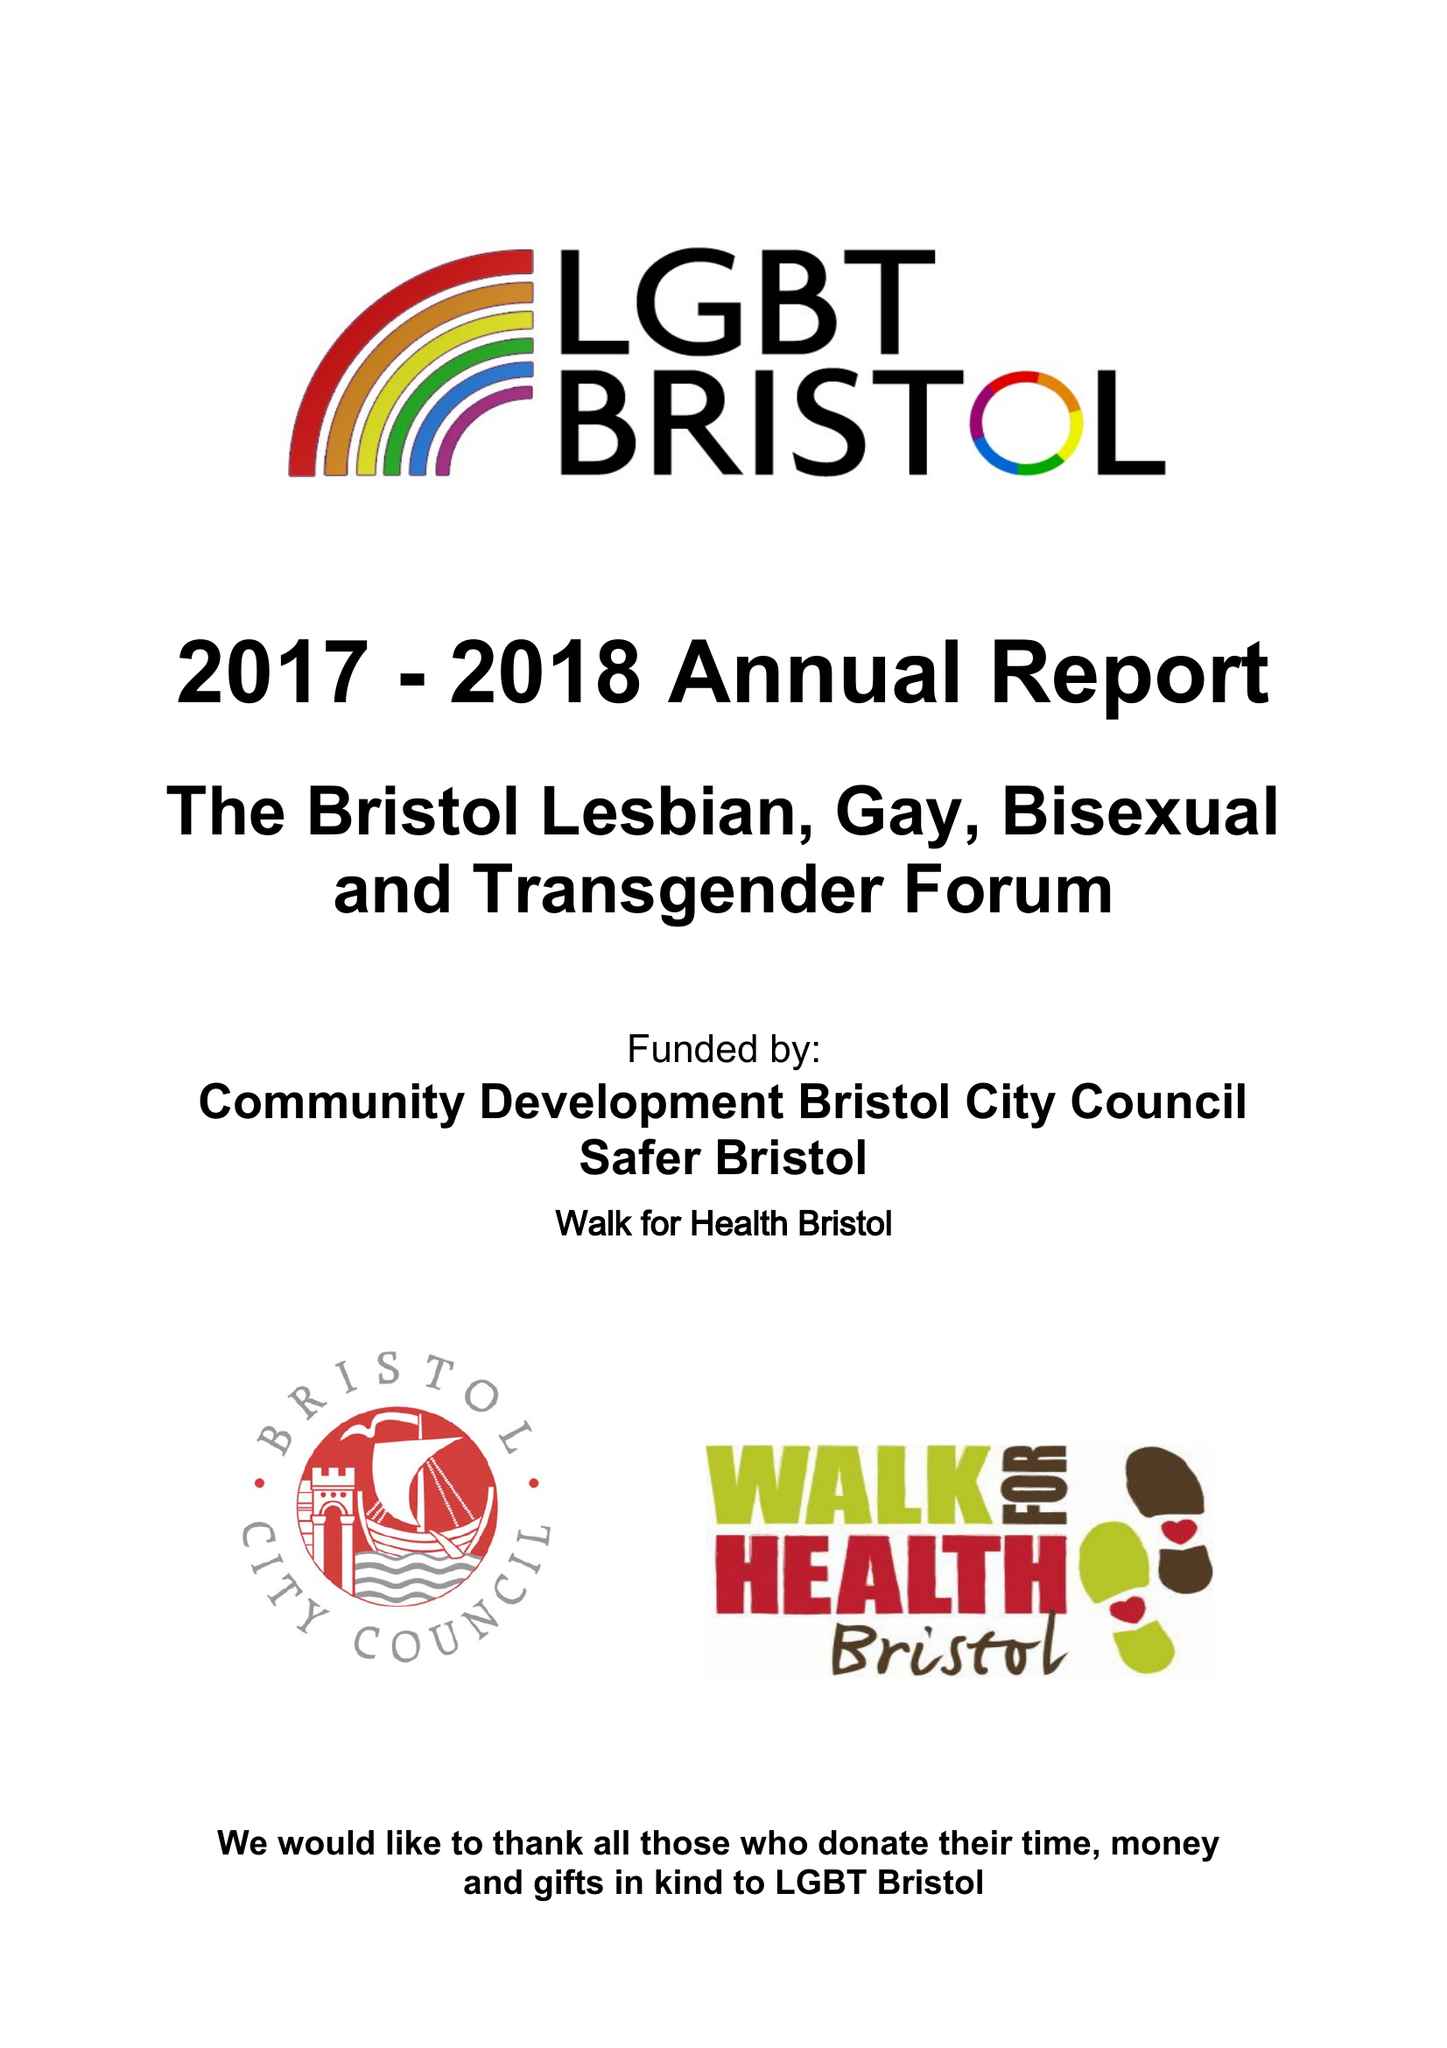What is the value for the address__street_line?
Answer the question using a single word or phrase. DAVENTRY ROAD 